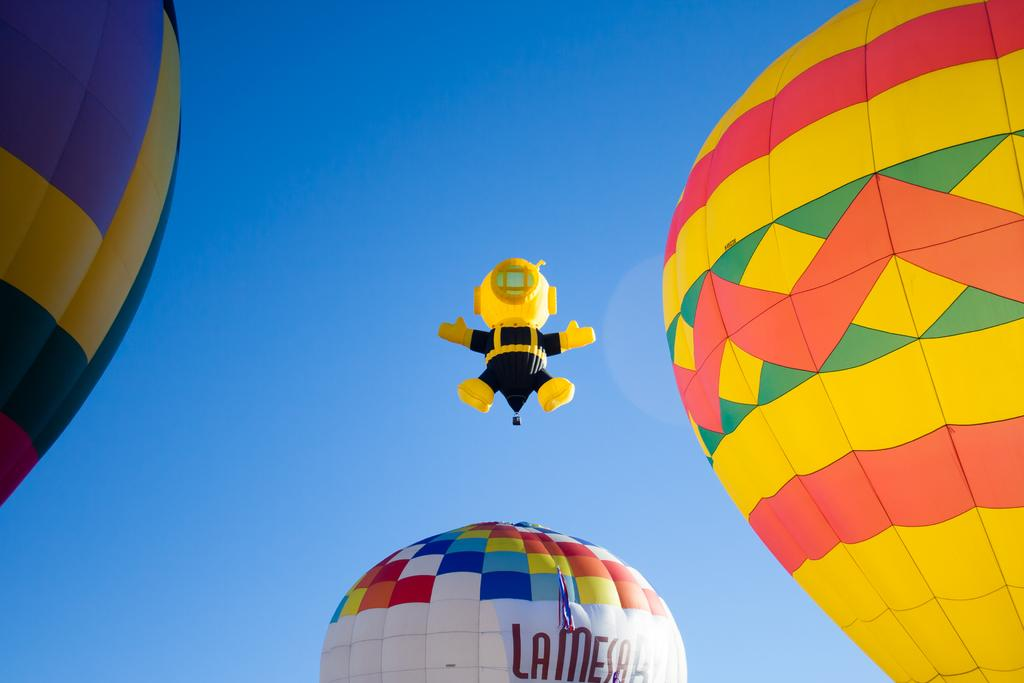<image>
Give a short and clear explanation of the subsequent image. Four big colorful balloons are flying in the sky and one has LA MESA on it. 